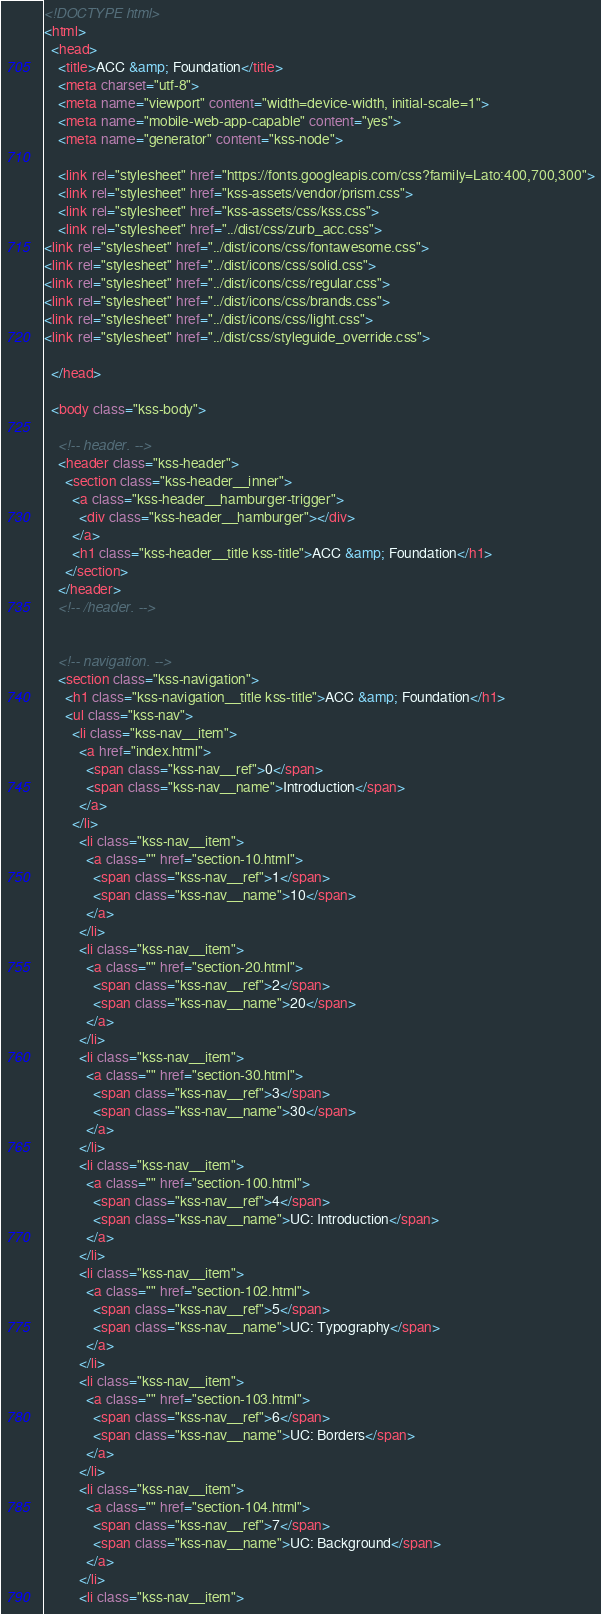Convert code to text. <code><loc_0><loc_0><loc_500><loc_500><_HTML_><!DOCTYPE html>
<html>
  <head>
    <title>ACC &amp; Foundation</title>
    <meta charset="utf-8">
    <meta name="viewport" content="width=device-width, initial-scale=1">
    <meta name="mobile-web-app-capable" content="yes">
    <meta name="generator" content="kss-node">

    <link rel="stylesheet" href="https://fonts.googleapis.com/css?family=Lato:400,700,300">
    <link rel="stylesheet" href="kss-assets/vendor/prism.css">
    <link rel="stylesheet" href="kss-assets/css/kss.css">
    <link rel="stylesheet" href="../dist/css/zurb_acc.css">
<link rel="stylesheet" href="../dist/icons/css/fontawesome.css">
<link rel="stylesheet" href="../dist/icons/css/solid.css">
<link rel="stylesheet" href="../dist/icons/css/regular.css">
<link rel="stylesheet" href="../dist/icons/css/brands.css">
<link rel="stylesheet" href="../dist/icons/css/light.css">
<link rel="stylesheet" href="../dist/css/styleguide_override.css">

  </head>

  <body class="kss-body">

    <!-- header. -->
    <header class="kss-header">
      <section class="kss-header__inner">
        <a class="kss-header__hamburger-trigger">
          <div class="kss-header__hamburger"></div>
        </a>
        <h1 class="kss-header__title kss-title">ACC &amp; Foundation</h1>
      </section>
    </header>
    <!-- /header. -->


    <!-- navigation. -->
    <section class="kss-navigation">
      <h1 class="kss-navigation__title kss-title">ACC &amp; Foundation</h1>
      <ul class="kss-nav">
        <li class="kss-nav__item">
          <a href="index.html">
            <span class="kss-nav__ref">0</span>
            <span class="kss-nav__name">Introduction</span>
          </a>
        </li>
          <li class="kss-nav__item">
            <a class="" href="section-10.html">
              <span class="kss-nav__ref">1</span>
              <span class="kss-nav__name">10</span>
            </a>
          </li>
          <li class="kss-nav__item">
            <a class="" href="section-20.html">
              <span class="kss-nav__ref">2</span>
              <span class="kss-nav__name">20</span>
            </a>
          </li>
          <li class="kss-nav__item">
            <a class="" href="section-30.html">
              <span class="kss-nav__ref">3</span>
              <span class="kss-nav__name">30</span>
            </a>
          </li>
          <li class="kss-nav__item">
            <a class="" href="section-100.html">
              <span class="kss-nav__ref">4</span>
              <span class="kss-nav__name">UC: Introduction</span>
            </a>
          </li>
          <li class="kss-nav__item">
            <a class="" href="section-102.html">
              <span class="kss-nav__ref">5</span>
              <span class="kss-nav__name">UC: Typography</span>
            </a>
          </li>
          <li class="kss-nav__item">
            <a class="" href="section-103.html">
              <span class="kss-nav__ref">6</span>
              <span class="kss-nav__name">UC: Borders</span>
            </a>
          </li>
          <li class="kss-nav__item">
            <a class="" href="section-104.html">
              <span class="kss-nav__ref">7</span>
              <span class="kss-nav__name">UC: Background</span>
            </a>
          </li>
          <li class="kss-nav__item"></code> 